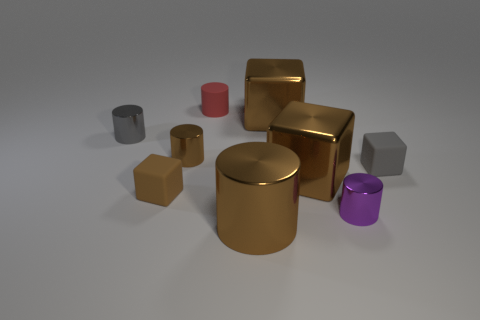Subtract all brown blocks. How many were subtracted if there are1brown blocks left? 2 Add 1 small cyan cubes. How many objects exist? 10 Subtract 3 cylinders. How many cylinders are left? 2 Add 4 large cubes. How many large cubes are left? 6 Add 5 brown shiny objects. How many brown shiny objects exist? 9 Subtract all gray cylinders. How many cylinders are left? 4 Subtract all brown cubes. How many cubes are left? 1 Subtract 0 cyan balls. How many objects are left? 9 Subtract all cylinders. How many objects are left? 4 Subtract all green blocks. Subtract all brown balls. How many blocks are left? 4 